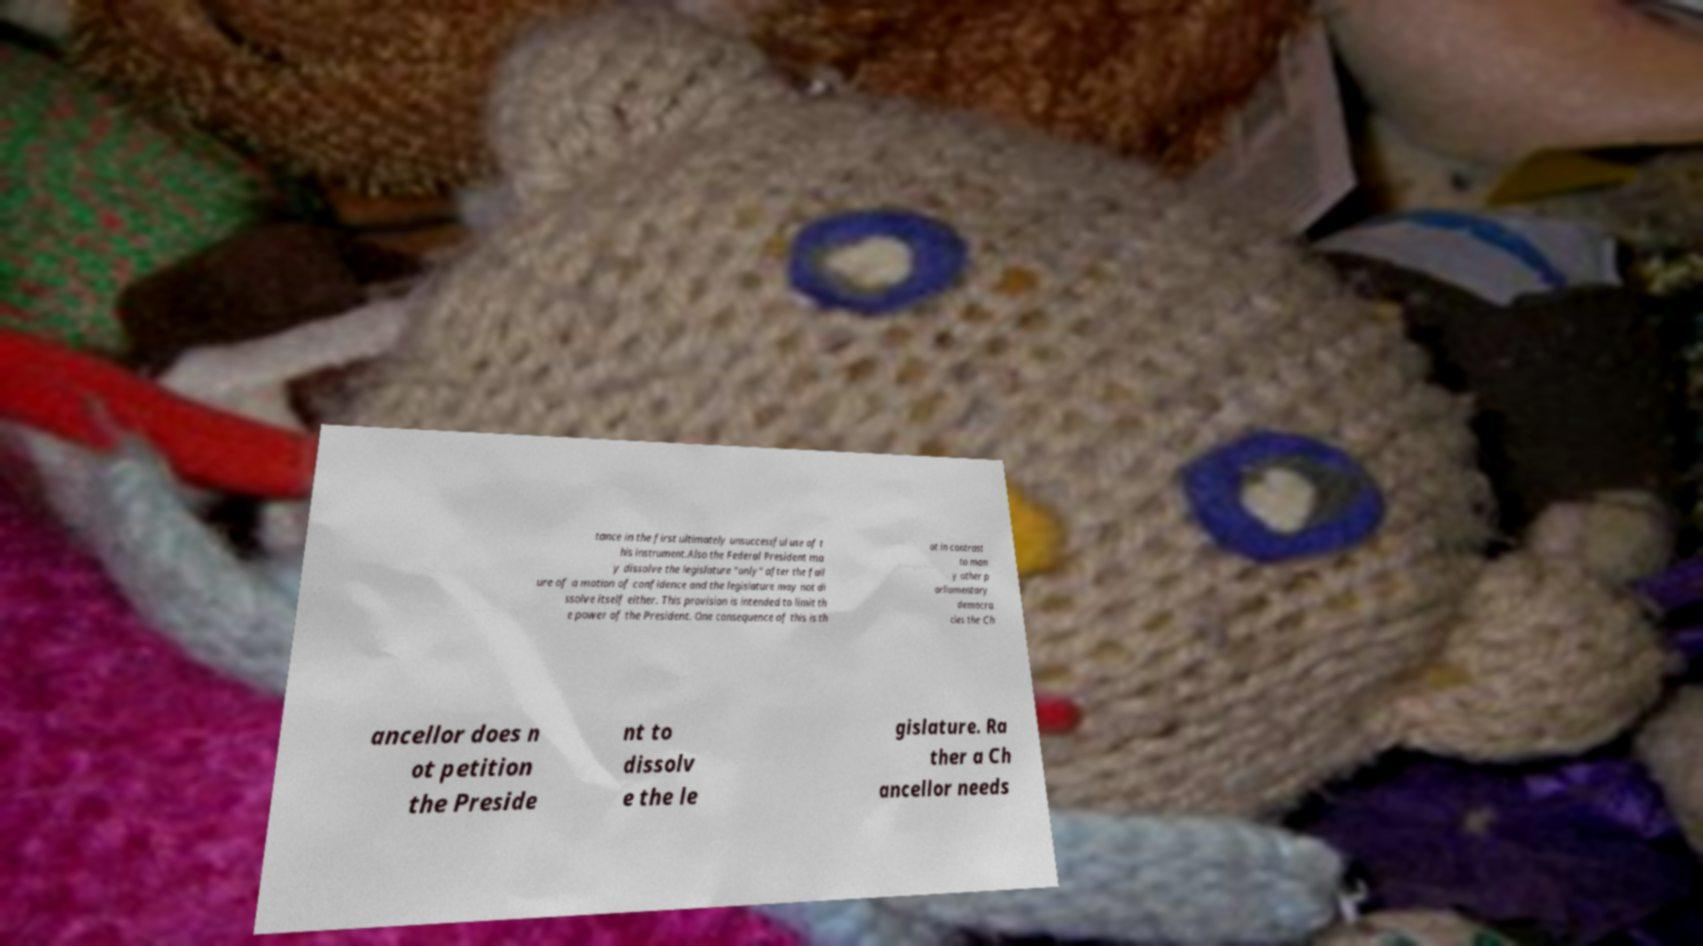Could you extract and type out the text from this image? tance in the first ultimately unsuccessful use of t his instrument.Also the Federal President ma y dissolve the legislature "only" after the fail ure of a motion of confidence and the legislature may not di ssolve itself either. This provision is intended to limit th e power of the President. One consequence of this is th at in contrast to man y other p arliamentary democra cies the Ch ancellor does n ot petition the Preside nt to dissolv e the le gislature. Ra ther a Ch ancellor needs 